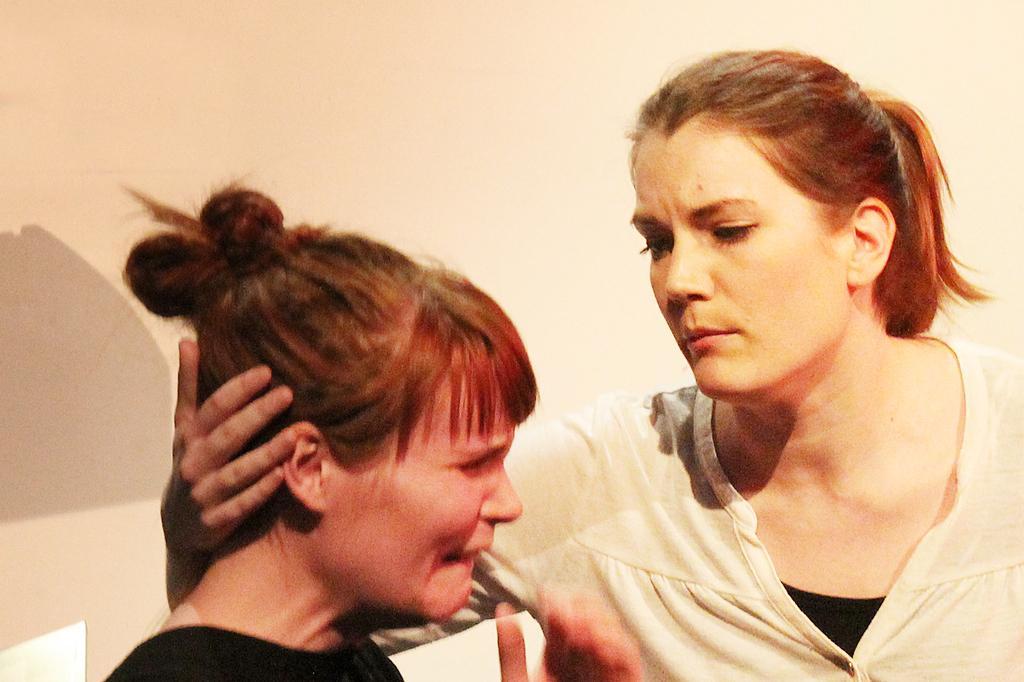How would you summarize this image in a sentence or two? This picture is taken inside the room. In this image, on the right side, we can see a woman wearing white color shirt and holding the head of the another woman. On the left side, we can also see another woman wearing black color dress. In the background, we can see a wall. 